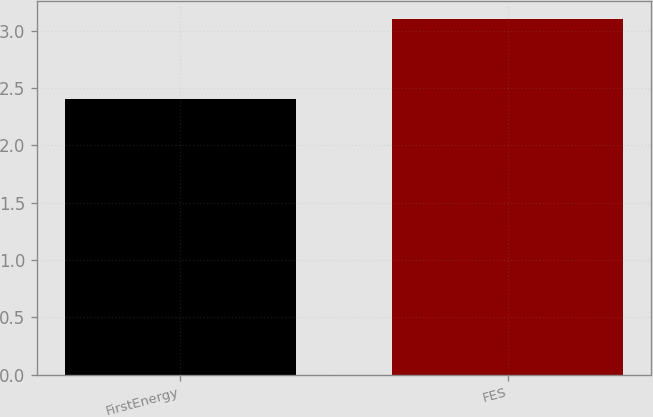Convert chart to OTSL. <chart><loc_0><loc_0><loc_500><loc_500><bar_chart><fcel>FirstEnergy<fcel>FES<nl><fcel>2.4<fcel>3.1<nl></chart> 